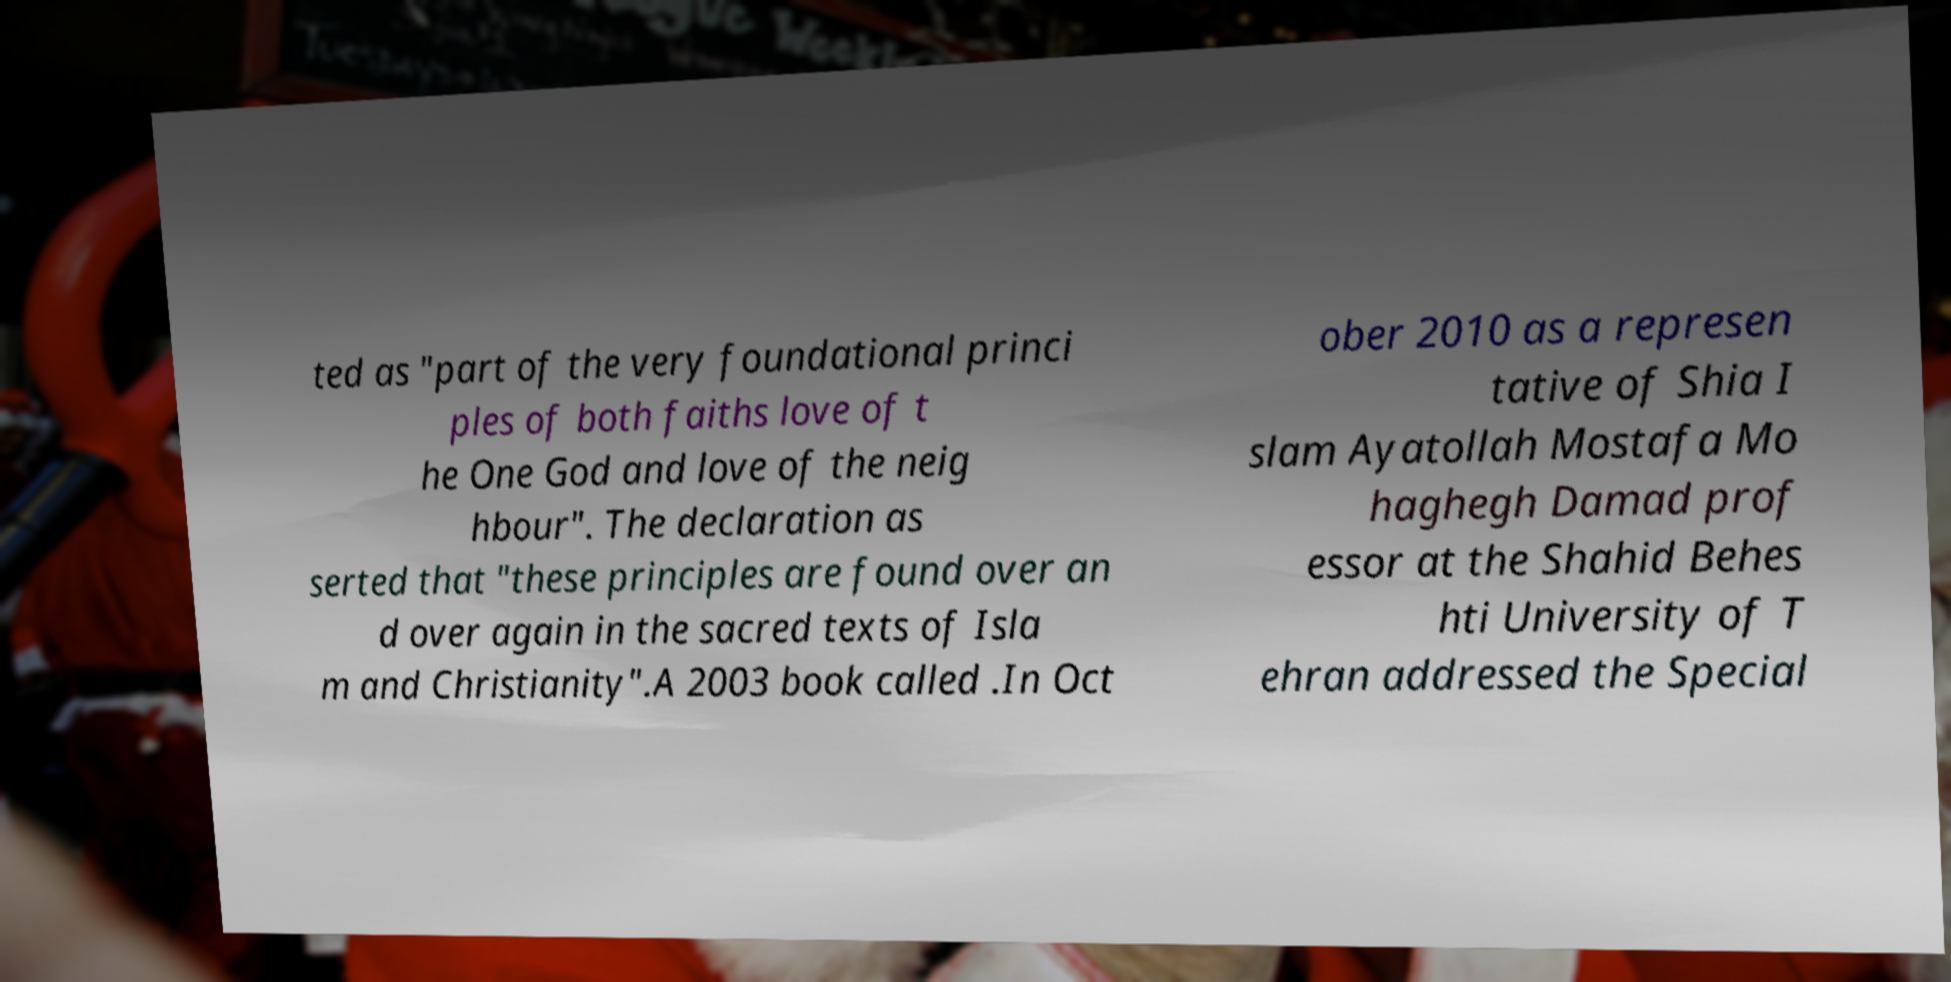Please identify and transcribe the text found in this image. ted as "part of the very foundational princi ples of both faiths love of t he One God and love of the neig hbour". The declaration as serted that "these principles are found over an d over again in the sacred texts of Isla m and Christianity".A 2003 book called .In Oct ober 2010 as a represen tative of Shia I slam Ayatollah Mostafa Mo haghegh Damad prof essor at the Shahid Behes hti University of T ehran addressed the Special 